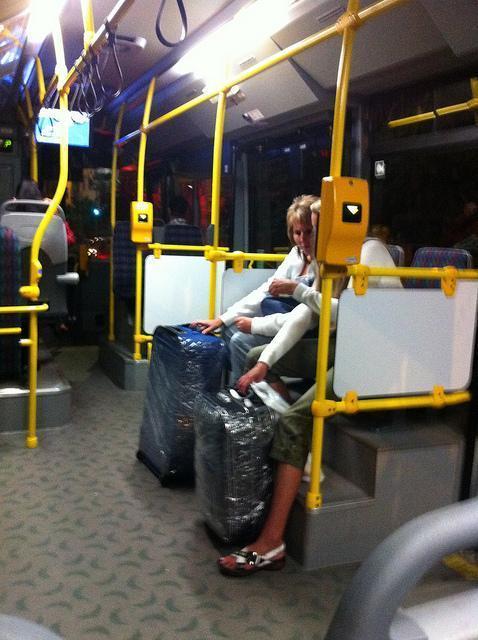How many people can be seen?
Give a very brief answer. 2. How many suitcases can be seen?
Give a very brief answer. 2. How many cars are to the right?
Give a very brief answer. 0. 